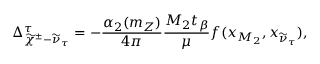Convert formula to latex. <formula><loc_0><loc_0><loc_500><loc_500>\Delta _ { \widetilde { \chi } ^ { \pm } - \widetilde { \nu } _ { \tau } } ^ { \tau } = - \frac { \alpha _ { 2 } ( m _ { Z } ) } { 4 \pi } \frac { M _ { 2 } t _ { \beta } } { \mu } f ( x _ { M _ { 2 } } , x _ { \widetilde { \nu } _ { \tau } } ) ,</formula> 